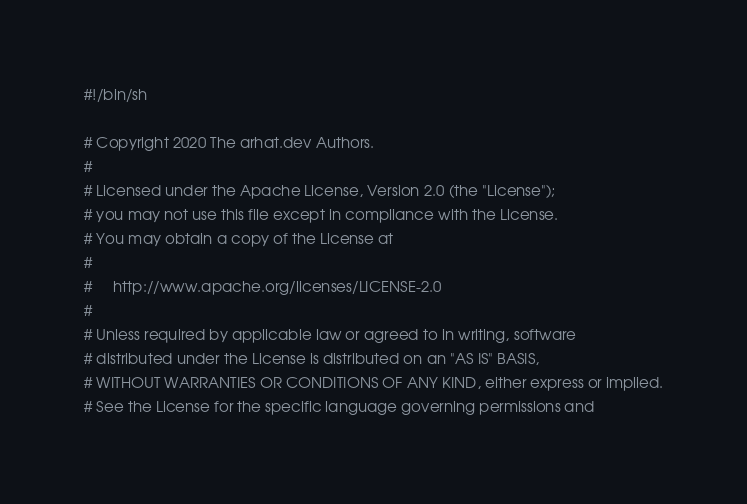Convert code to text. <code><loc_0><loc_0><loc_500><loc_500><_Bash_>#!/bin/sh

# Copyright 2020 The arhat.dev Authors.
#
# Licensed under the Apache License, Version 2.0 (the "License");
# you may not use this file except in compliance with the License.
# You may obtain a copy of the License at
#
#     http://www.apache.org/licenses/LICENSE-2.0
#
# Unless required by applicable law or agreed to in writing, software
# distributed under the License is distributed on an "AS IS" BASIS,
# WITHOUT WARRANTIES OR CONDITIONS OF ANY KIND, either express or implied.
# See the License for the specific language governing permissions and</code> 